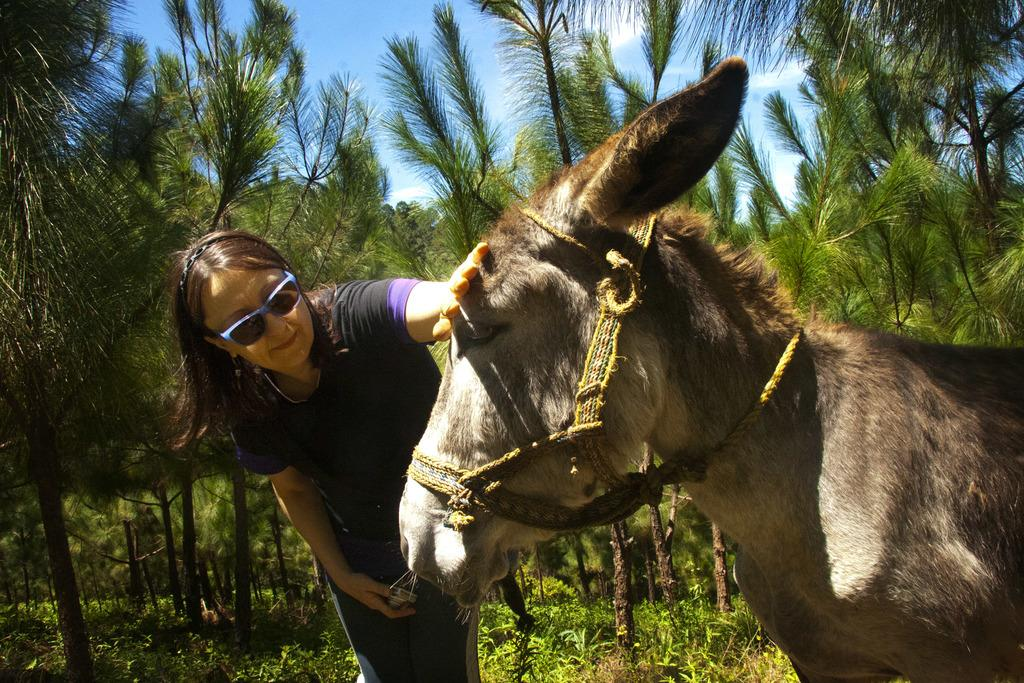What animal is present in the picture? There is a donkey in the picture. Who is present in the picture besides the donkey? There is a woman in the picture. What type of vegetation can be seen in the picture? There are trees and plants in the picture. How would you describe the sky in the picture? The sky is blue and cloudy in the picture. What is the woman's opinion on the string in the picture? There is no string present in the picture, so it is not possible to determine the woman's opinion on it. 